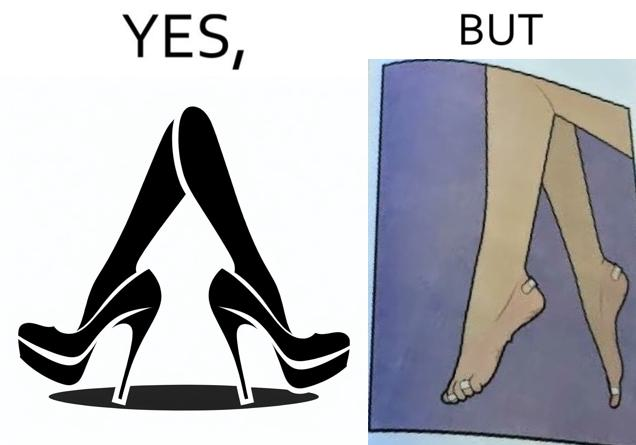What do you see in each half of this image? In the left part of the image: a pair of high heeled shoes In the right part of the image: A pair of feet, blistered and red, with bandages 